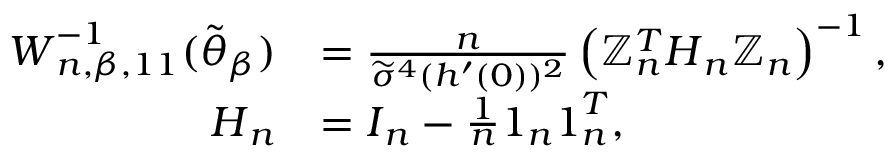Convert formula to latex. <formula><loc_0><loc_0><loc_500><loc_500>\begin{array} { r l } { W _ { n , \beta , 1 1 } ^ { - 1 } ( \widetilde { \theta } _ { \beta } ) } & { = \frac { n } { \widetilde { \sigma } ^ { 4 } ( h ^ { \prime } ( 0 ) ) ^ { 2 } } \left ( \mathbb { Z } _ { n } ^ { T } H _ { n } \mathbb { Z } _ { n } \right ) ^ { - 1 } , } \\ { H _ { n } } & { = I _ { n } - \frac { 1 } { n } 1 _ { n } 1 _ { n } ^ { T } , } \end{array}</formula> 